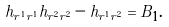<formula> <loc_0><loc_0><loc_500><loc_500>h _ { r ^ { 1 } r ^ { 1 } } h _ { r ^ { 2 } r ^ { 2 } } - h _ { r ^ { 1 } r ^ { 2 } } = B _ { 1 } .</formula> 